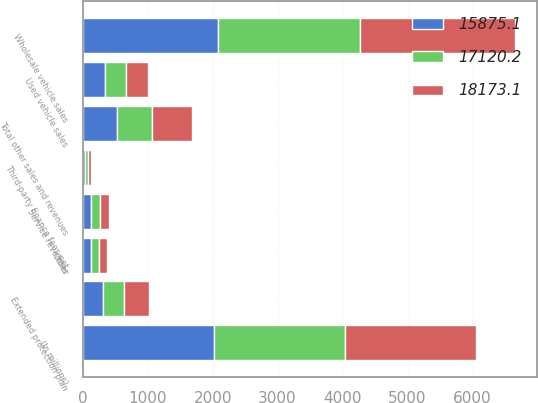Convert chart. <chart><loc_0><loc_0><loc_500><loc_500><stacked_bar_chart><ecel><fcel>(In millions)<fcel>Used vehicle sales<fcel>Wholesale vehicle sales<fcel>Extended protection plan<fcel>Third-party finance fees net<fcel>Service revenues<fcel>Other<fcel>Total other sales and revenues<nl><fcel>18173.1<fcel>2019<fcel>336.4<fcel>2393<fcel>382.5<fcel>43.4<fcel>136.8<fcel>131.4<fcel>607.3<nl><fcel>17120.2<fcel>2018<fcel>336.4<fcel>2181.2<fcel>336.4<fcel>49.9<fcel>134<fcel>126.2<fcel>546.7<nl><fcel>15875.1<fcel>2017<fcel>336.4<fcel>2082.5<fcel>305.5<fcel>38.4<fcel>133.9<fcel>121<fcel>522<nl></chart> 